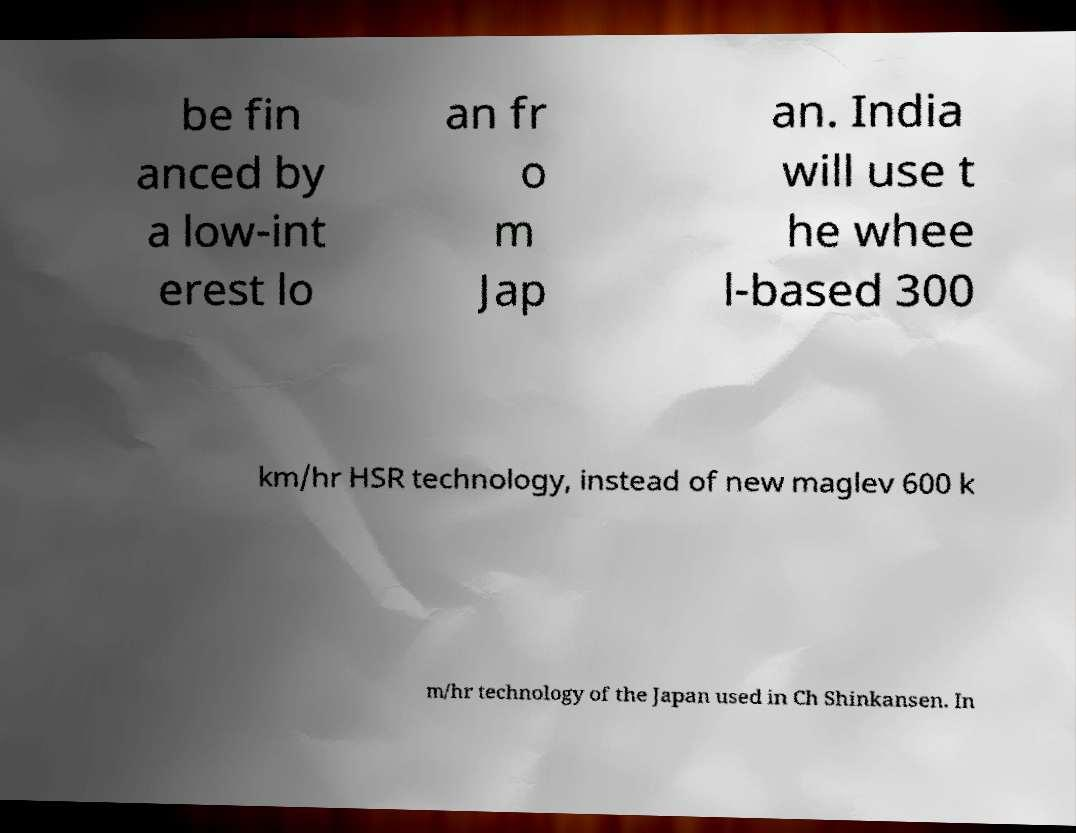Could you extract and type out the text from this image? be fin anced by a low-int erest lo an fr o m Jap an. India will use t he whee l-based 300 km/hr HSR technology, instead of new maglev 600 k m/hr technology of the Japan used in Ch Shinkansen. In 